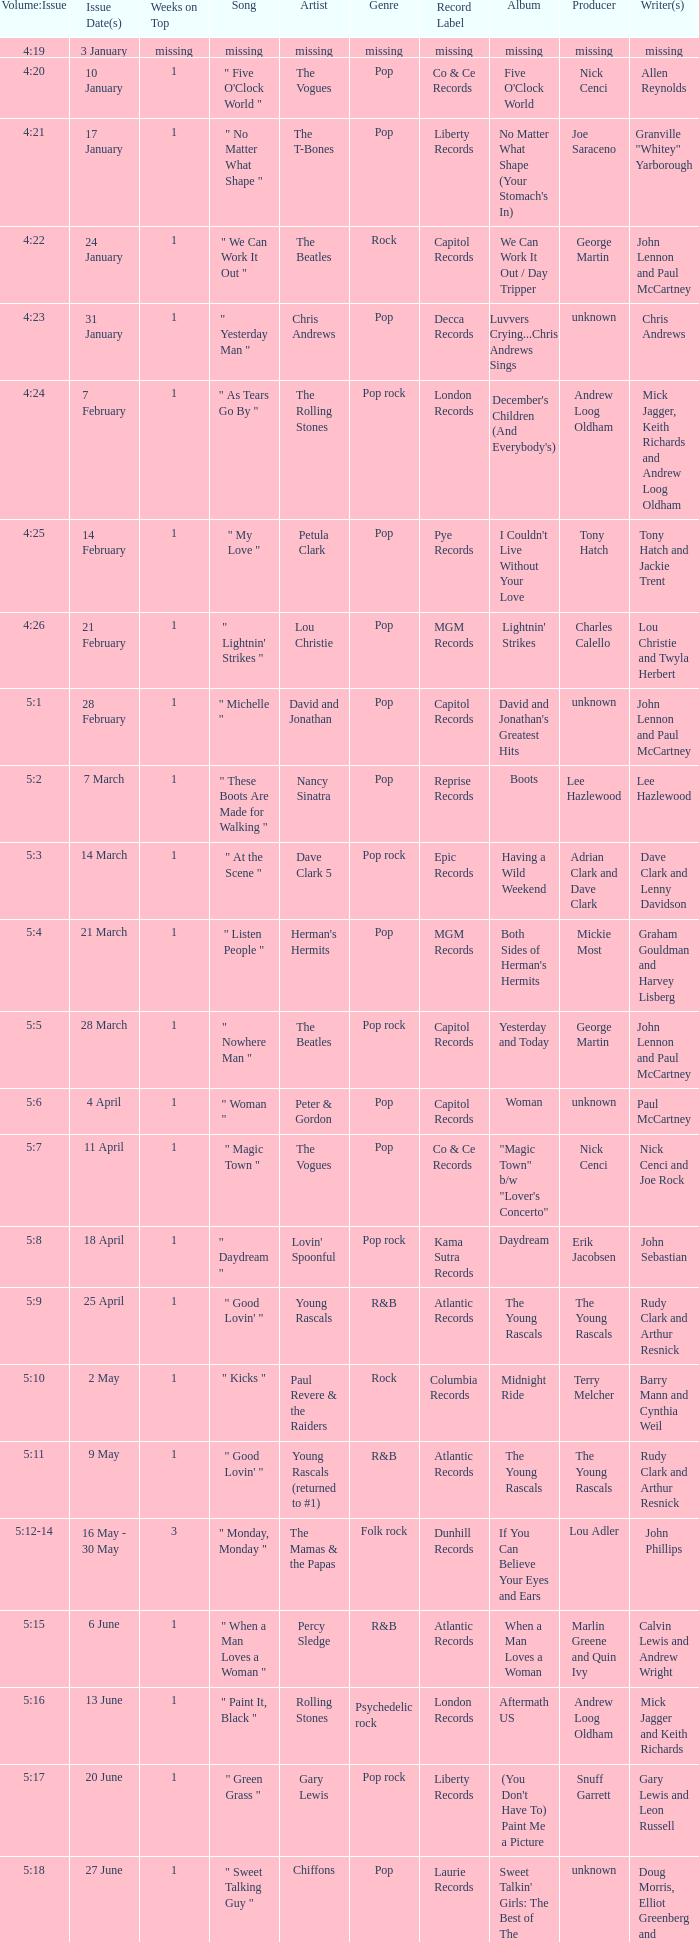An artist of the Beatles with an issue date(s) of 19 September has what as the listed weeks on top? 1.0. 